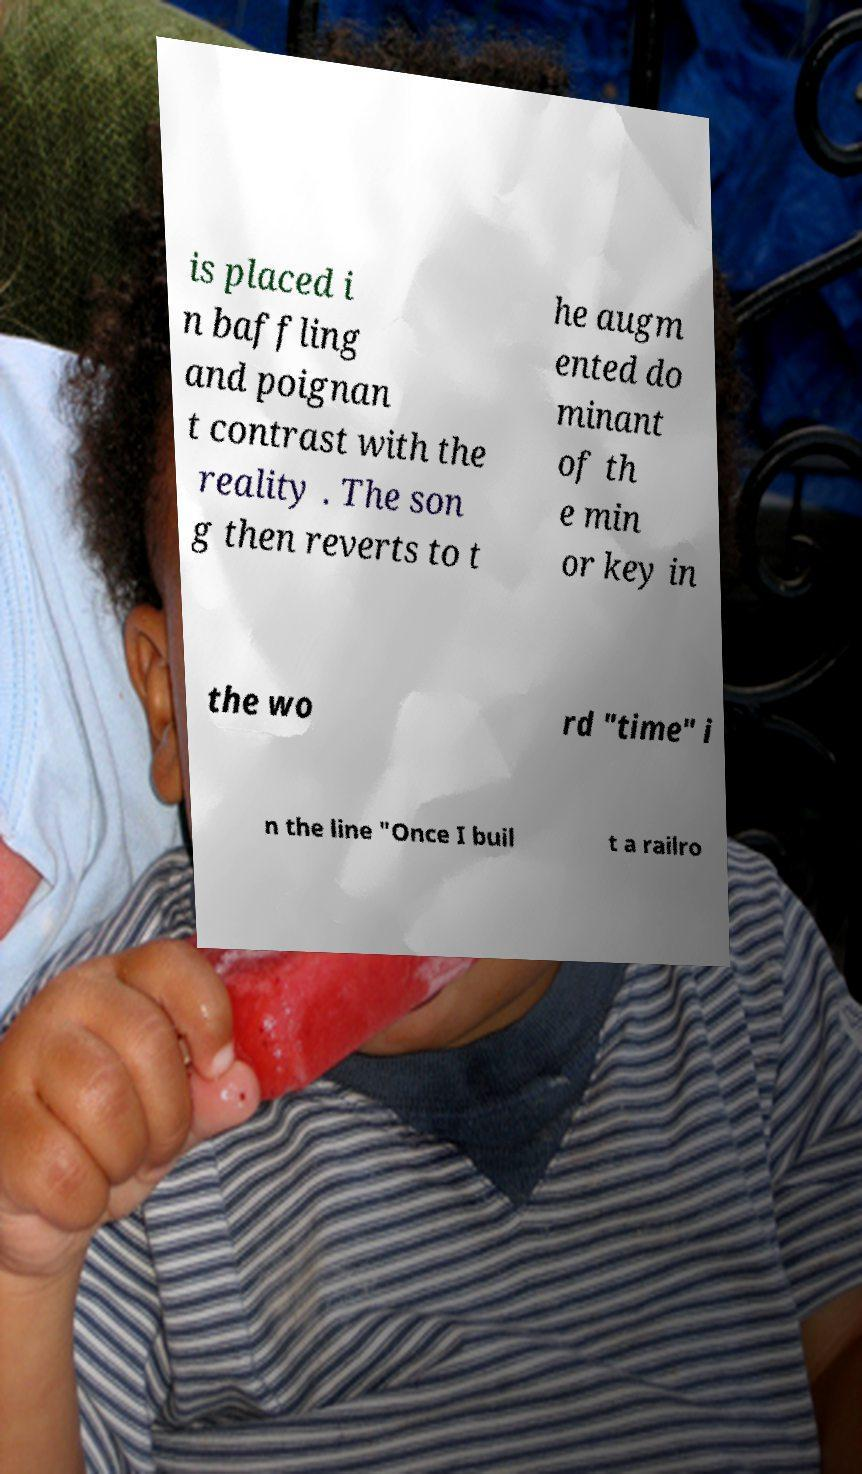Can you read and provide the text displayed in the image?This photo seems to have some interesting text. Can you extract and type it out for me? is placed i n baffling and poignan t contrast with the reality . The son g then reverts to t he augm ented do minant of th e min or key in the wo rd "time" i n the line "Once I buil t a railro 